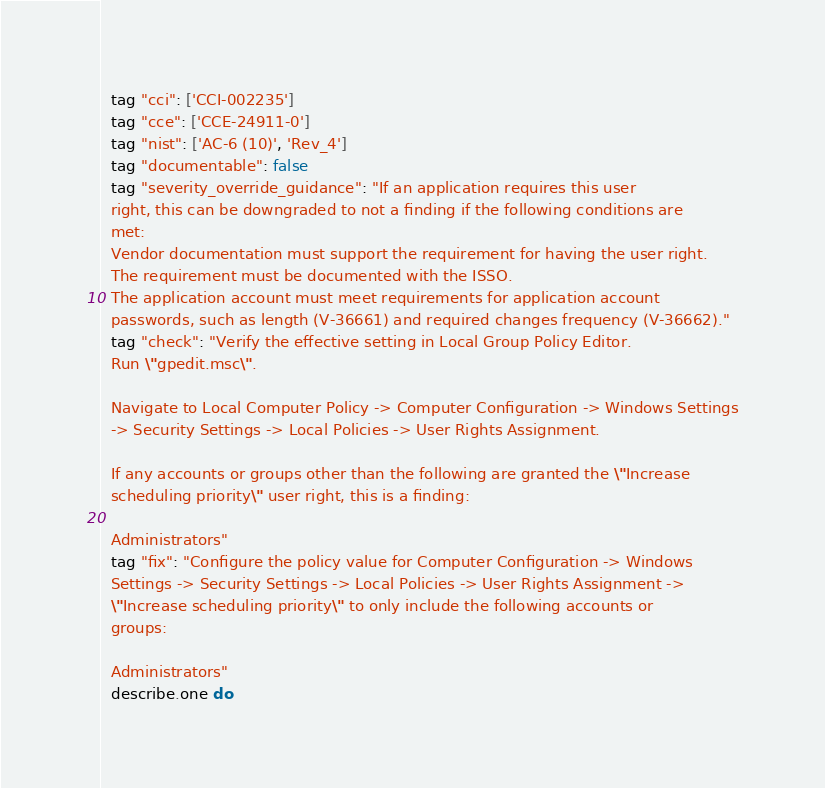<code> <loc_0><loc_0><loc_500><loc_500><_Ruby_>  tag "cci": ['CCI-002235']
  tag "cce": ['CCE-24911-0']
  tag "nist": ['AC-6 (10)', 'Rev_4']
  tag "documentable": false
  tag "severity_override_guidance": "If an application requires this user
  right, this can be downgraded to not a finding if the following conditions are
  met:
  Vendor documentation must support the requirement for having the user right.
  The requirement must be documented with the ISSO.
  The application account must meet requirements for application account
  passwords, such as length (V-36661) and required changes frequency (V-36662)."
  tag "check": "Verify the effective setting in Local Group Policy Editor.
  Run \"gpedit.msc\".

  Navigate to Local Computer Policy -> Computer Configuration -> Windows Settings
  -> Security Settings -> Local Policies -> User Rights Assignment.

  If any accounts or groups other than the following are granted the \"Increase
  scheduling priority\" user right, this is a finding:

  Administrators"
  tag "fix": "Configure the policy value for Computer Configuration -> Windows
  Settings -> Security Settings -> Local Policies -> User Rights Assignment ->
  \"Increase scheduling priority\" to only include the following accounts or
  groups:

  Administrators"
  describe.one do</code> 